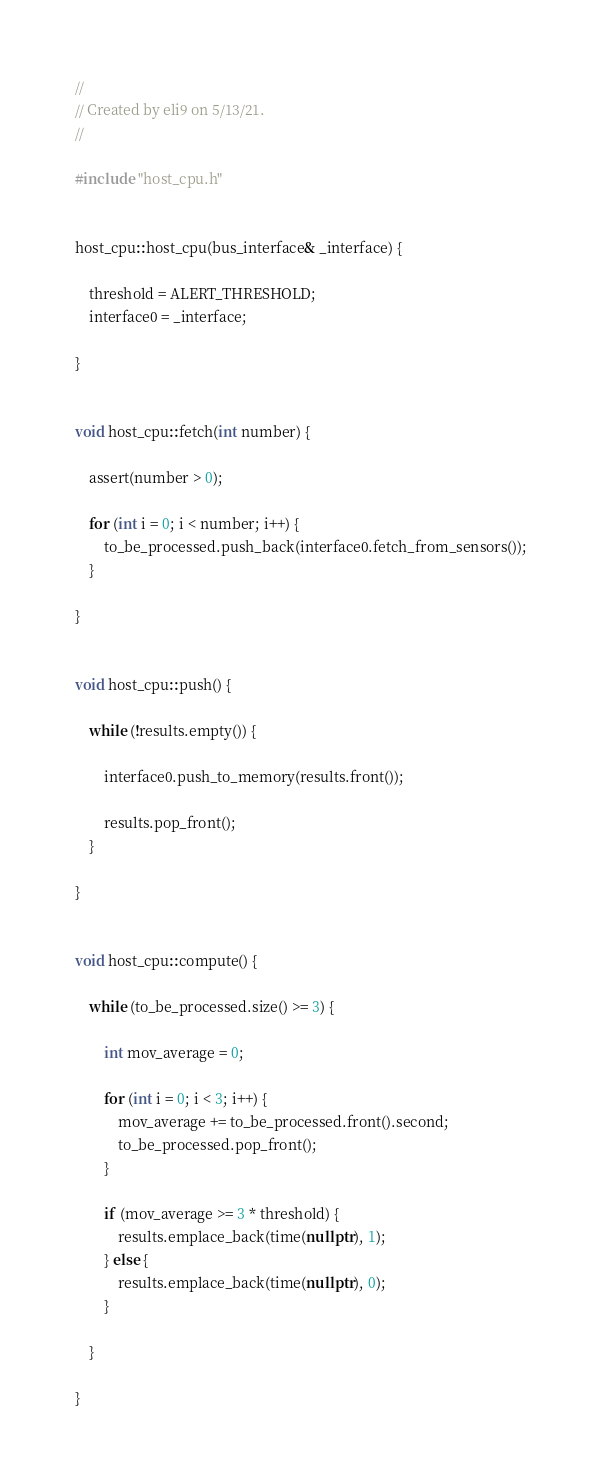Convert code to text. <code><loc_0><loc_0><loc_500><loc_500><_C++_>//
// Created by eli9 on 5/13/21.
//

#include "host_cpu.h"


host_cpu::host_cpu(bus_interface& _interface) {

    threshold = ALERT_THRESHOLD;
    interface0 = _interface;

}


void host_cpu::fetch(int number) {

    assert(number > 0);

    for (int i = 0; i < number; i++) {
        to_be_processed.push_back(interface0.fetch_from_sensors());
    }

}


void host_cpu::push() {

    while (!results.empty()) {

        interface0.push_to_memory(results.front());

        results.pop_front();
    }

}


void host_cpu::compute() {

    while (to_be_processed.size() >= 3) {

        int mov_average = 0;

        for (int i = 0; i < 3; i++) {
            mov_average += to_be_processed.front().second;
            to_be_processed.pop_front();
        }

        if (mov_average >= 3 * threshold) {
            results.emplace_back(time(nullptr), 1);
        } else {
            results.emplace_back(time(nullptr), 0);
        }

    }

}</code> 